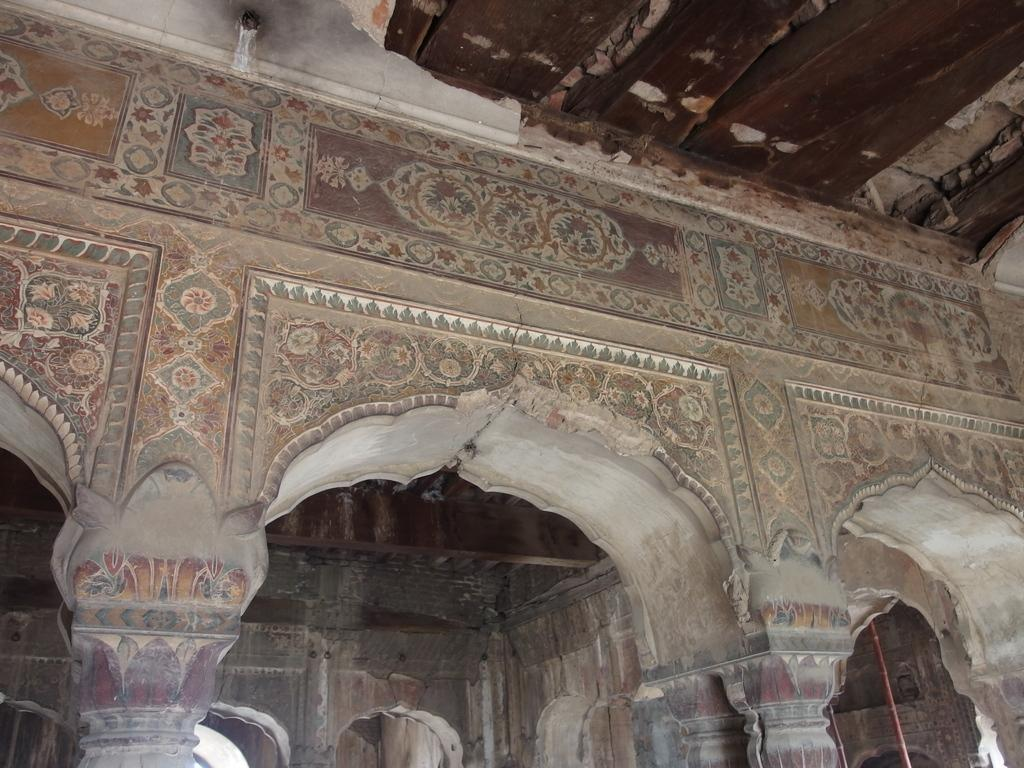What structures are present in the foreground of the image? There are arches in the foreground of the image, and they are connected to a wall. What type of ceiling is visible in the image? There is a wooden ceiling at the top of the image. Are there any similar structures in the background of the image? Yes, there are arches in the background of the image, and there is also a wall. How many zebras can be seen jumping over the arches in the image? There are no zebras present in the image, and they cannot be seen jumping over the arches. 